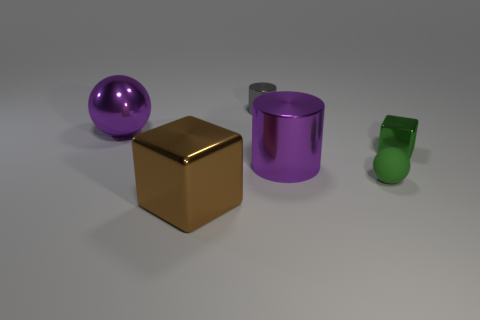Add 1 small objects. How many objects exist? 7 Subtract 0 blue balls. How many objects are left? 6 Subtract all cylinders. How many objects are left? 4 Subtract all small rubber cylinders. Subtract all purple cylinders. How many objects are left? 5 Add 2 purple cylinders. How many purple cylinders are left? 3 Add 2 tiny objects. How many tiny objects exist? 5 